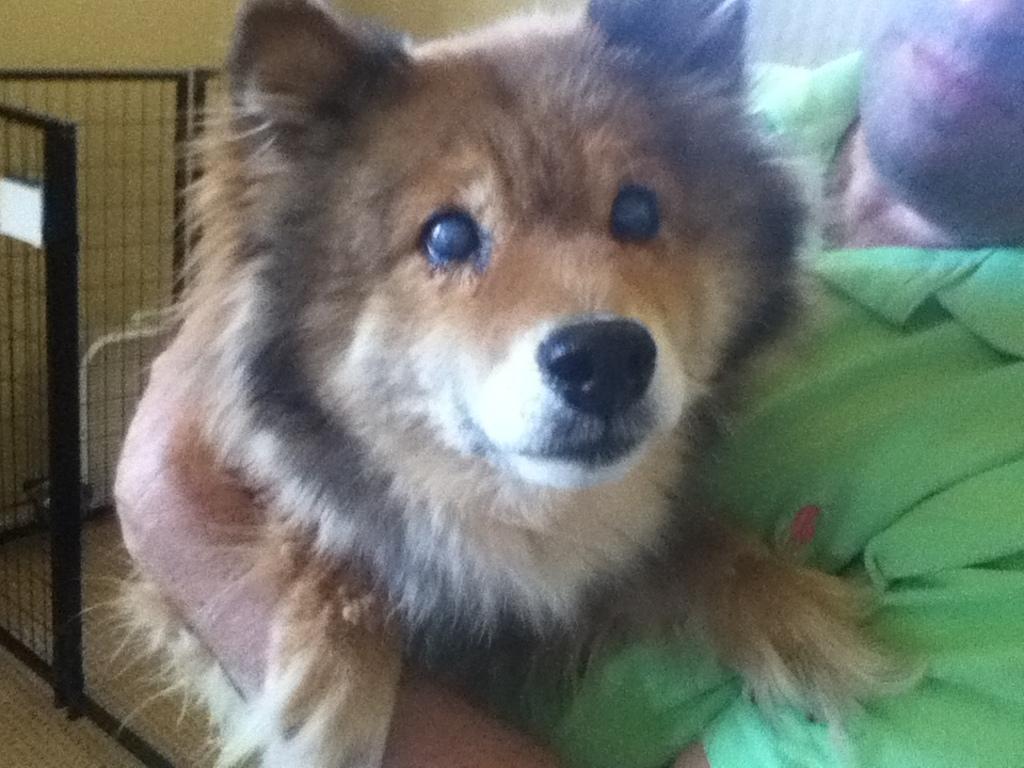Could you give a brief overview of what you see in this image? In the image there is a man with green t-shirt is holding the dog in his hand. Behind them there is a fencing. 